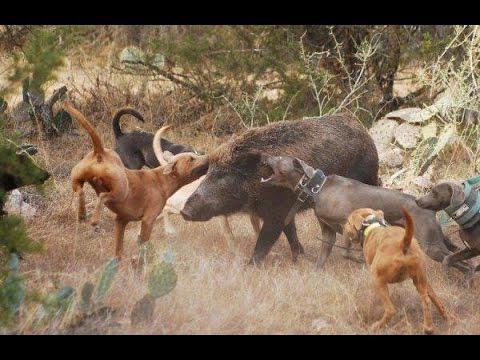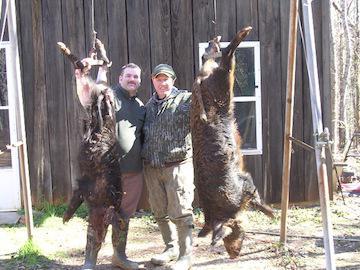The first image is the image on the left, the second image is the image on the right. For the images shown, is this caption "In total, two dead hogs are shown." true? Answer yes or no. Yes. The first image is the image on the left, the second image is the image on the right. Analyze the images presented: Is the assertion "Two hunters are posing with their kill in the image on the right." valid? Answer yes or no. Yes. 